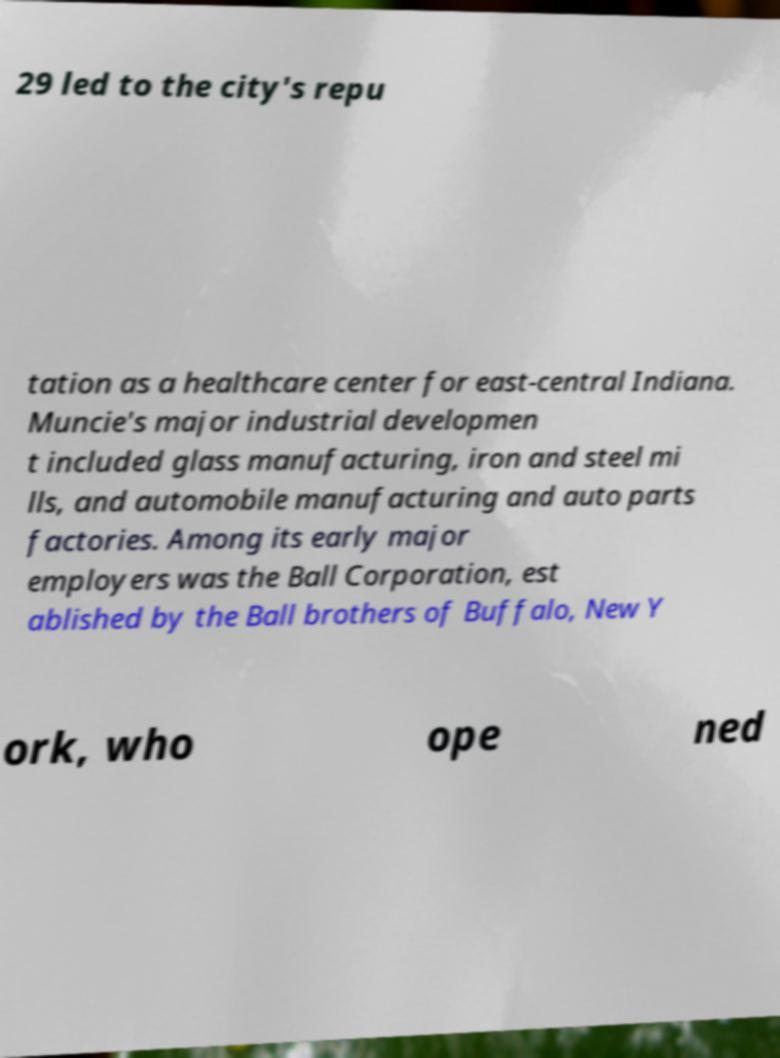Could you assist in decoding the text presented in this image and type it out clearly? 29 led to the city's repu tation as a healthcare center for east-central Indiana. Muncie's major industrial developmen t included glass manufacturing, iron and steel mi lls, and automobile manufacturing and auto parts factories. Among its early major employers was the Ball Corporation, est ablished by the Ball brothers of Buffalo, New Y ork, who ope ned 